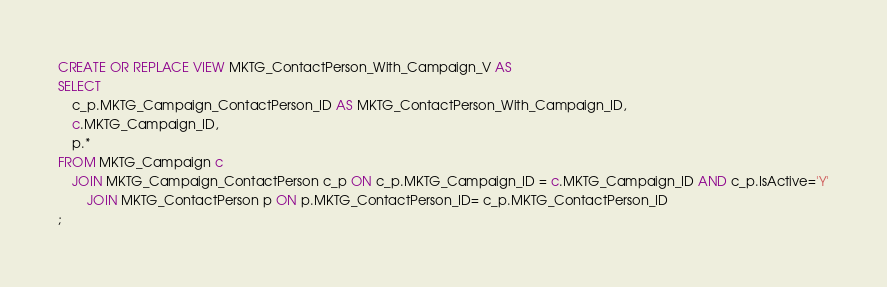<code> <loc_0><loc_0><loc_500><loc_500><_SQL_>
CREATE OR REPLACE VIEW MKTG_ContactPerson_With_Campaign_V AS
SELECT 
	c_p.MKTG_Campaign_ContactPerson_ID AS MKTG_ContactPerson_With_Campaign_ID,
	c.MKTG_Campaign_ID, 
	p.*
FROM MKTG_Campaign c
	JOIN MKTG_Campaign_ContactPerson c_p ON c_p.MKTG_Campaign_ID = c.MKTG_Campaign_ID AND c_p.IsActive='Y'
		JOIN MKTG_ContactPerson p ON p.MKTG_ContactPerson_ID= c_p.MKTG_ContactPerson_ID
;
</code> 